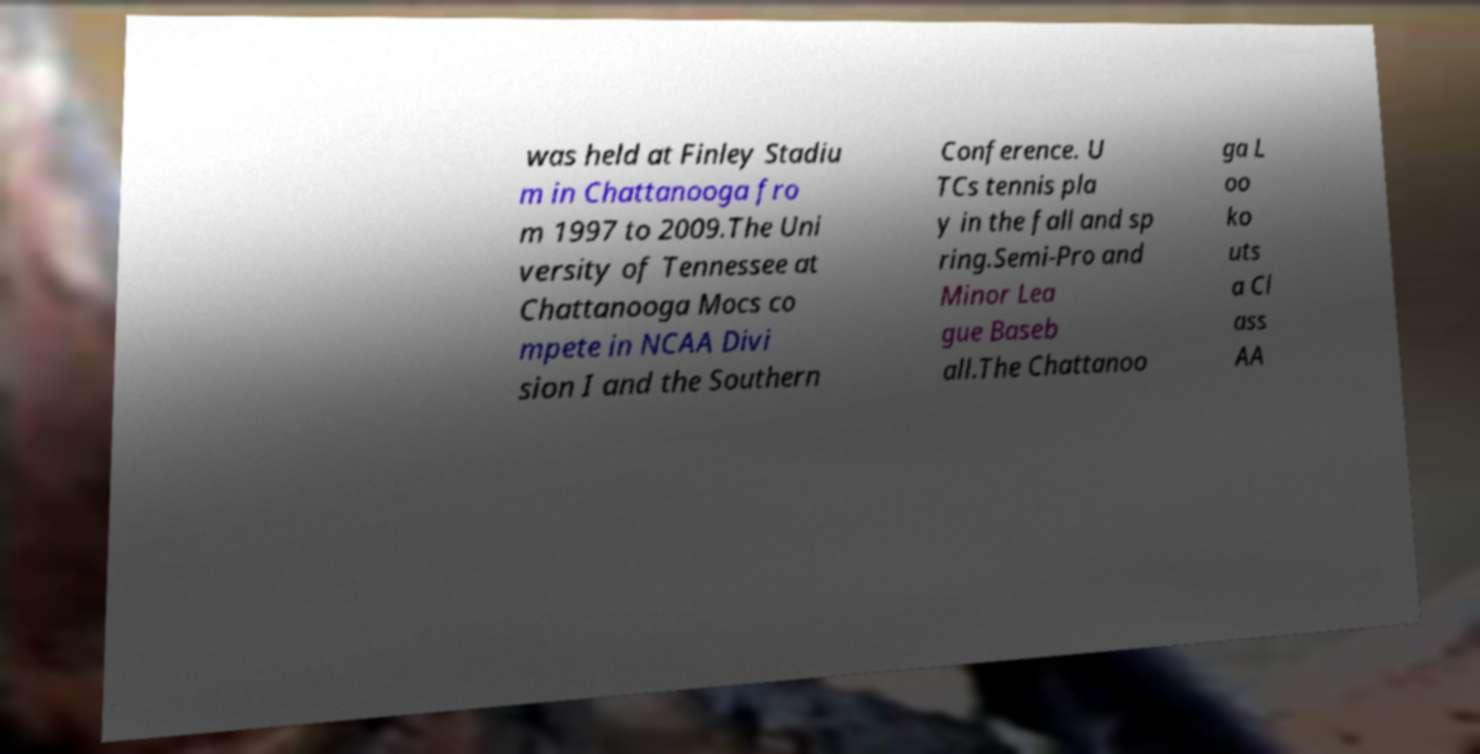What messages or text are displayed in this image? I need them in a readable, typed format. was held at Finley Stadiu m in Chattanooga fro m 1997 to 2009.The Uni versity of Tennessee at Chattanooga Mocs co mpete in NCAA Divi sion I and the Southern Conference. U TCs tennis pla y in the fall and sp ring.Semi-Pro and Minor Lea gue Baseb all.The Chattanoo ga L oo ko uts a Cl ass AA 